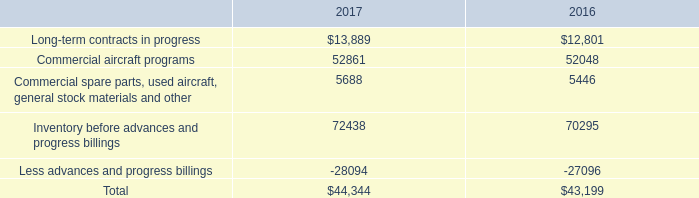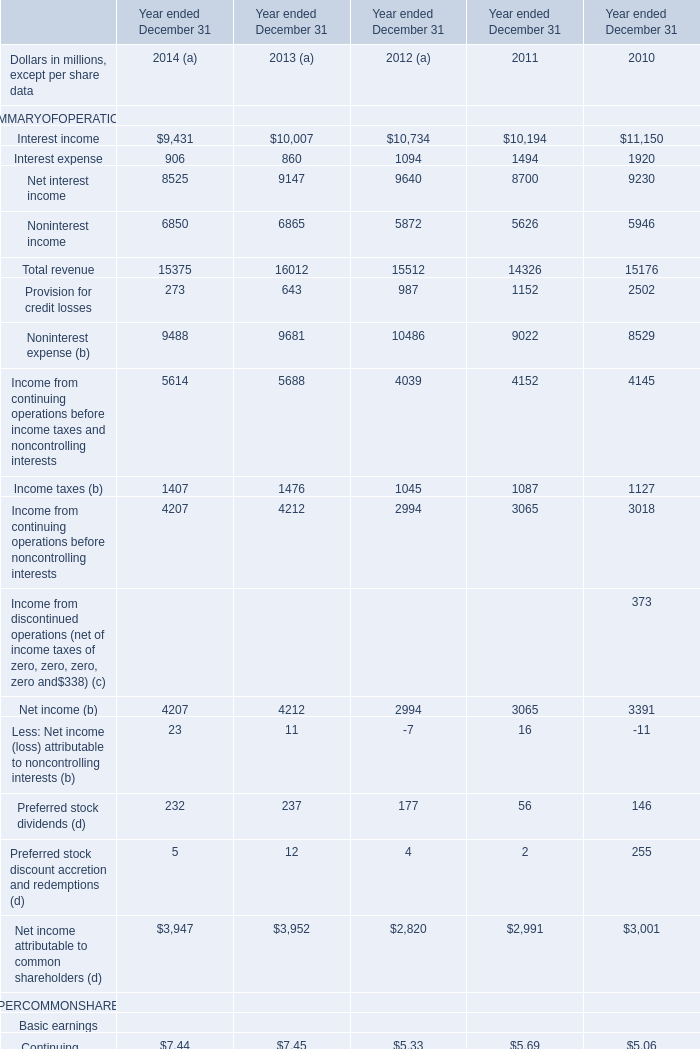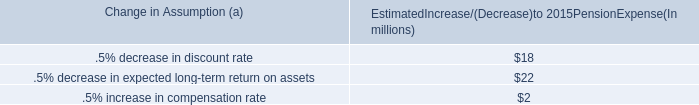What is the sum of Commercial aircraft programs of 2016, Interest expense of Year ended December 31 2010, and Income from continuing operations before noncontrolling interests of Year ended December 31 2010 ? 
Computations: ((52048.0 + 1920.0) + 3018.0)
Answer: 56986.0. 